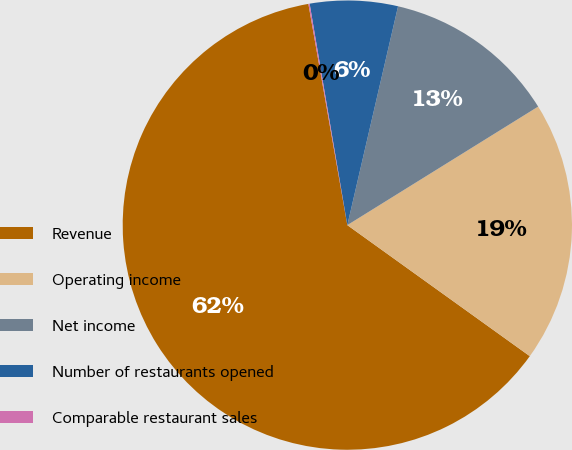Convert chart. <chart><loc_0><loc_0><loc_500><loc_500><pie_chart><fcel>Revenue<fcel>Operating income<fcel>Net income<fcel>Number of restaurants opened<fcel>Comparable restaurant sales<nl><fcel>62.32%<fcel>18.76%<fcel>12.53%<fcel>6.31%<fcel>0.09%<nl></chart> 